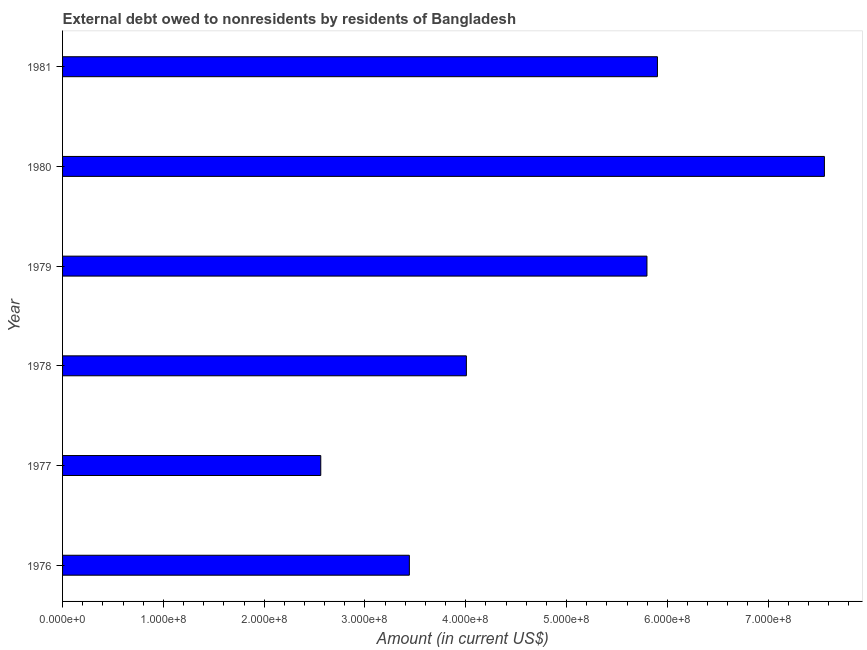What is the title of the graph?
Offer a very short reply. External debt owed to nonresidents by residents of Bangladesh. What is the debt in 1978?
Give a very brief answer. 4.01e+08. Across all years, what is the maximum debt?
Your answer should be very brief. 7.56e+08. Across all years, what is the minimum debt?
Your answer should be compact. 2.56e+08. In which year was the debt minimum?
Offer a terse response. 1977. What is the sum of the debt?
Keep it short and to the point. 2.93e+09. What is the difference between the debt in 1977 and 1978?
Your answer should be compact. -1.44e+08. What is the average debt per year?
Offer a terse response. 4.88e+08. What is the median debt?
Make the answer very short. 4.90e+08. In how many years, is the debt greater than 560000000 US$?
Offer a very short reply. 3. What is the ratio of the debt in 1976 to that in 1979?
Your response must be concise. 0.59. Is the difference between the debt in 1976 and 1980 greater than the difference between any two years?
Provide a succinct answer. No. What is the difference between the highest and the second highest debt?
Provide a succinct answer. 1.66e+08. Is the sum of the debt in 1976 and 1980 greater than the maximum debt across all years?
Your answer should be very brief. Yes. What is the difference between the highest and the lowest debt?
Your answer should be compact. 5.00e+08. In how many years, is the debt greater than the average debt taken over all years?
Offer a very short reply. 3. What is the difference between two consecutive major ticks on the X-axis?
Your answer should be compact. 1.00e+08. Are the values on the major ticks of X-axis written in scientific E-notation?
Your answer should be very brief. Yes. What is the Amount (in current US$) of 1976?
Keep it short and to the point. 3.44e+08. What is the Amount (in current US$) in 1977?
Your response must be concise. 2.56e+08. What is the Amount (in current US$) in 1978?
Offer a terse response. 4.01e+08. What is the Amount (in current US$) in 1979?
Offer a terse response. 5.80e+08. What is the Amount (in current US$) of 1980?
Your answer should be very brief. 7.56e+08. What is the Amount (in current US$) of 1981?
Provide a short and direct response. 5.90e+08. What is the difference between the Amount (in current US$) in 1976 and 1977?
Your response must be concise. 8.79e+07. What is the difference between the Amount (in current US$) in 1976 and 1978?
Offer a very short reply. -5.66e+07. What is the difference between the Amount (in current US$) in 1976 and 1979?
Provide a short and direct response. -2.36e+08. What is the difference between the Amount (in current US$) in 1976 and 1980?
Provide a succinct answer. -4.12e+08. What is the difference between the Amount (in current US$) in 1976 and 1981?
Keep it short and to the point. -2.46e+08. What is the difference between the Amount (in current US$) in 1977 and 1978?
Provide a short and direct response. -1.44e+08. What is the difference between the Amount (in current US$) in 1977 and 1979?
Offer a terse response. -3.24e+08. What is the difference between the Amount (in current US$) in 1977 and 1980?
Provide a succinct answer. -5.00e+08. What is the difference between the Amount (in current US$) in 1977 and 1981?
Your response must be concise. -3.34e+08. What is the difference between the Amount (in current US$) in 1978 and 1979?
Offer a very short reply. -1.79e+08. What is the difference between the Amount (in current US$) in 1978 and 1980?
Keep it short and to the point. -3.55e+08. What is the difference between the Amount (in current US$) in 1978 and 1981?
Give a very brief answer. -1.90e+08. What is the difference between the Amount (in current US$) in 1979 and 1980?
Ensure brevity in your answer.  -1.76e+08. What is the difference between the Amount (in current US$) in 1979 and 1981?
Your response must be concise. -1.04e+07. What is the difference between the Amount (in current US$) in 1980 and 1981?
Give a very brief answer. 1.66e+08. What is the ratio of the Amount (in current US$) in 1976 to that in 1977?
Offer a very short reply. 1.34. What is the ratio of the Amount (in current US$) in 1976 to that in 1978?
Provide a succinct answer. 0.86. What is the ratio of the Amount (in current US$) in 1976 to that in 1979?
Ensure brevity in your answer.  0.59. What is the ratio of the Amount (in current US$) in 1976 to that in 1980?
Make the answer very short. 0.46. What is the ratio of the Amount (in current US$) in 1976 to that in 1981?
Make the answer very short. 0.58. What is the ratio of the Amount (in current US$) in 1977 to that in 1978?
Your answer should be very brief. 0.64. What is the ratio of the Amount (in current US$) in 1977 to that in 1979?
Your response must be concise. 0.44. What is the ratio of the Amount (in current US$) in 1977 to that in 1980?
Give a very brief answer. 0.34. What is the ratio of the Amount (in current US$) in 1977 to that in 1981?
Your response must be concise. 0.43. What is the ratio of the Amount (in current US$) in 1978 to that in 1979?
Your answer should be compact. 0.69. What is the ratio of the Amount (in current US$) in 1978 to that in 1980?
Provide a succinct answer. 0.53. What is the ratio of the Amount (in current US$) in 1978 to that in 1981?
Offer a very short reply. 0.68. What is the ratio of the Amount (in current US$) in 1979 to that in 1980?
Ensure brevity in your answer.  0.77. What is the ratio of the Amount (in current US$) in 1979 to that in 1981?
Your answer should be very brief. 0.98. What is the ratio of the Amount (in current US$) in 1980 to that in 1981?
Keep it short and to the point. 1.28. 